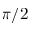<formula> <loc_0><loc_0><loc_500><loc_500>\pi / 2</formula> 